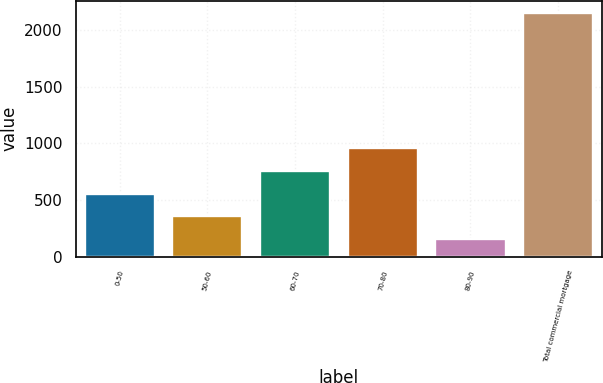<chart> <loc_0><loc_0><loc_500><loc_500><bar_chart><fcel>0-50<fcel>50-60<fcel>60-70<fcel>70-80<fcel>80-90<fcel>Total commercial mortgage<nl><fcel>555.6<fcel>355.8<fcel>755.4<fcel>955.2<fcel>156<fcel>2154<nl></chart> 